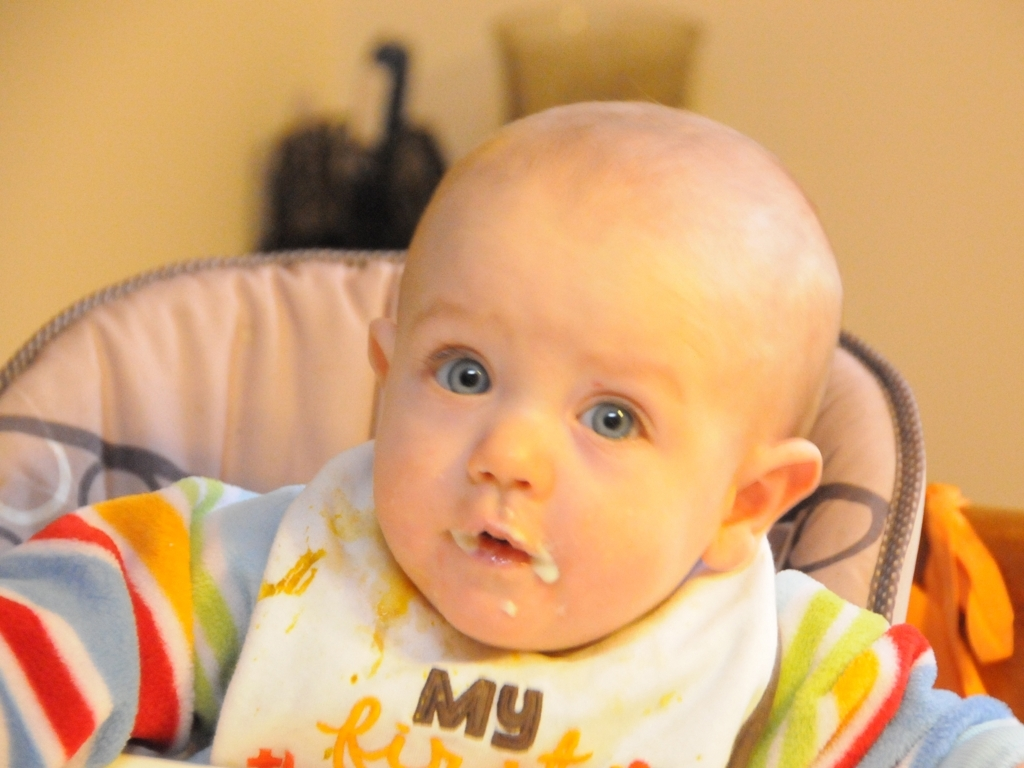What is the mood captured in the image? The image seems to capture a candid moment full of innocence and curiosity. The baby appears both surprised and engaged, suggesting a spontaneous reaction, possibly to a new sight or sound. Can you guess what might have caused the baby’s reaction? Given the baby’s wide eyes and slightly open mouth, it might be a response to something unexpected or fascinating in their environment, like hearing a novel sound or seeing a burst of color from a toy. 